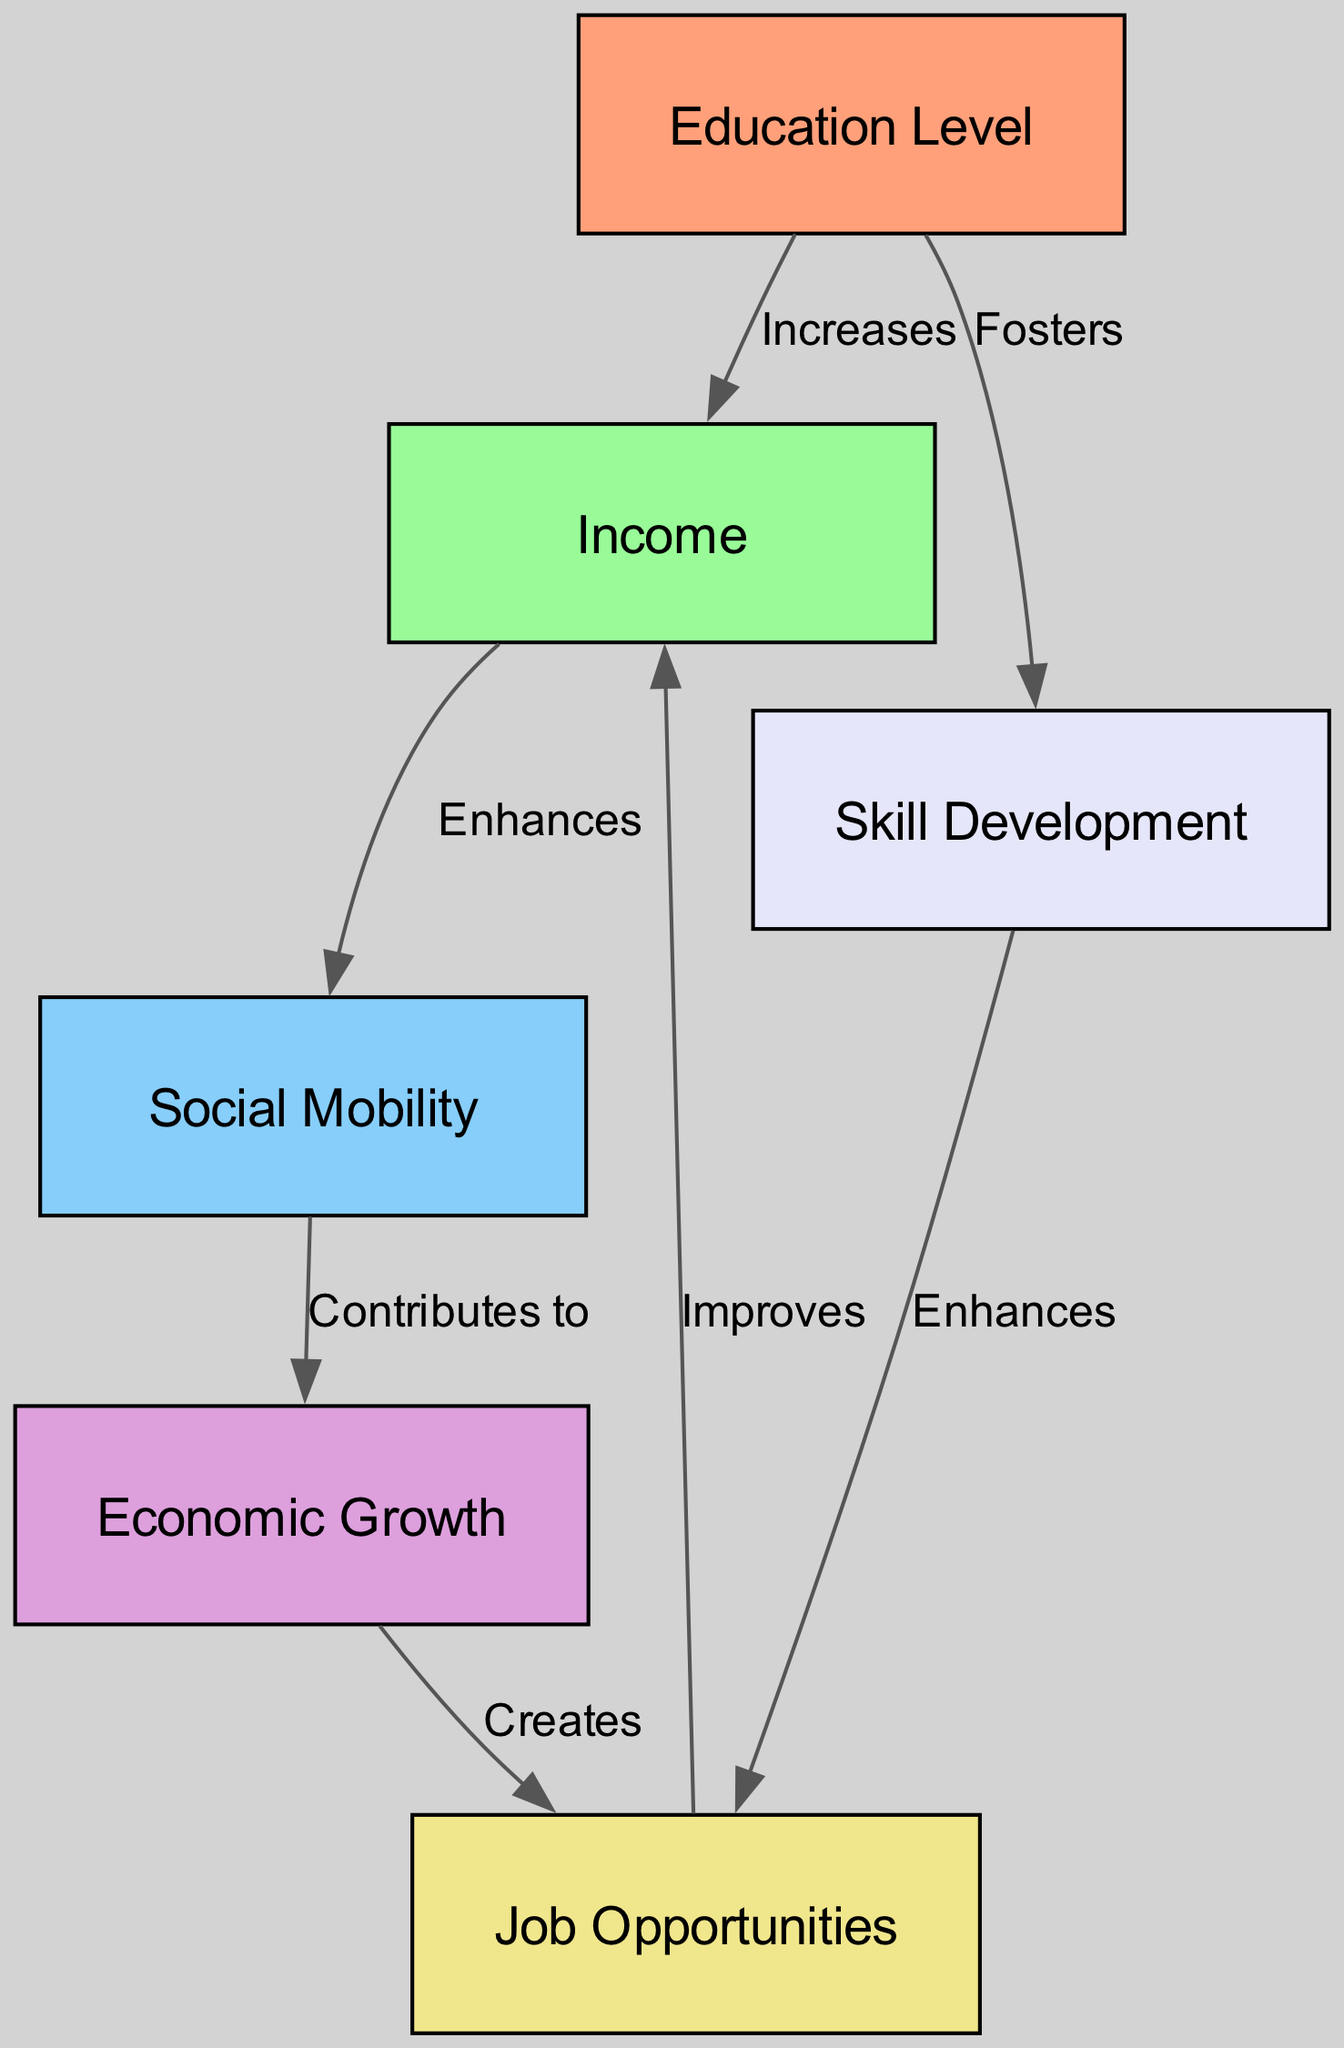What are the total number of nodes in the diagram? The diagram contains a "nodes" section with a total of six distinct items listed under it. Each item represents an important concept in the relationships.
Answer: 6 What is the relationship type between income and social mobility? The diagram shows an edge labeled "Enhances" connecting the "income" node to the "social mobility" node, indicating that income positively affects social mobility.
Answer: Enhances What node directly contributes to economic growth? The node "social mobility" is connected to the "economic growth" node with an edge labeled "Contributes to," meaning that social mobility plays a direct role in contributing to economic growth.
Answer: Social Mobility Which node fosters skill development? The "education" node is connected by an edge labeled "Fosters" to the "skill development" node, indicating that education is the source that promotes or encourages skill development.
Answer: Education What is the last node created due to economic growth? According to the diagram, "economic growth" creates "job opportunities," showing that the creation of job opportunities is a direct result of economic growth.
Answer: Job Opportunities How does education impact income in the diagram? The edge between the "education" and "income" nodes is labeled "Increases," which means that an increase in education level results in a corresponding increase in income.
Answer: Increases What is the flow of influence from education to economic growth? The flow begins at "education," which increases "income," then income enhances "social mobility," social mobility contributes to "economic growth." This sequential influence highlights how education indirectly impacts economic growth.
Answer: Education → Income → Social Mobility → Economic Growth How many edges are present in the diagram? The "edges" section consists of six connections between the nodes. This count reflects the number of relationships depicted in the diagram.
Answer: 6 Which two nodes are connected by an edge labeled 'Enhances'? The edge labeled "Enhances" connects the nodes "income" and "social mobility," showcasing that an increase in income enhances social mobility.
Answer: Income and Social Mobility 